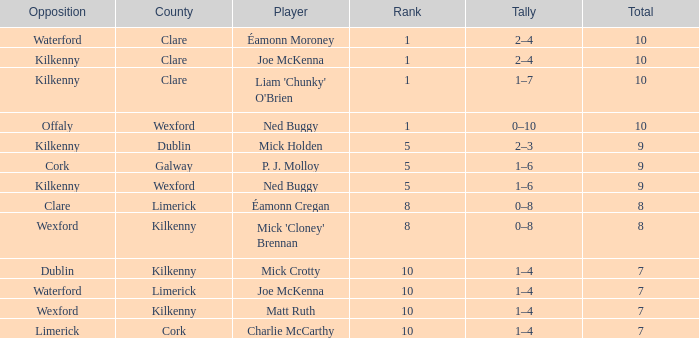What is galway county's total? 9.0. 